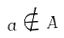Convert formula to latex. <formula><loc_0><loc_0><loc_500><loc_500>a \notin A</formula> 